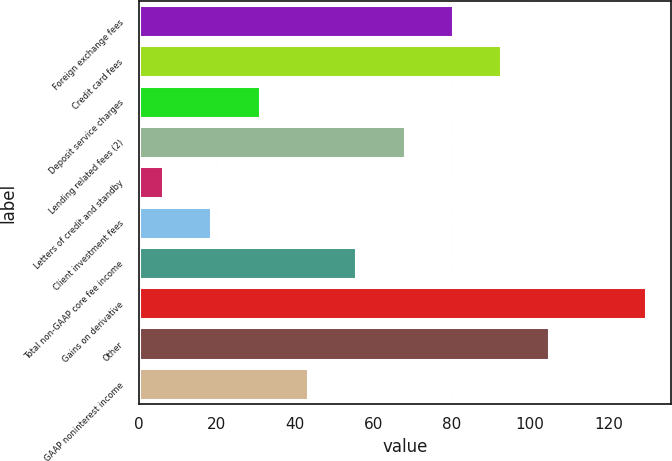<chart> <loc_0><loc_0><loc_500><loc_500><bar_chart><fcel>Foreign exchange fees<fcel>Credit card fees<fcel>Deposit service charges<fcel>Lending related fees (2)<fcel>Letters of credit and standby<fcel>Client investment fees<fcel>Total non-GAAP core fee income<fcel>Gains on derivative<fcel>Other<fcel>GAAP noninterest income<nl><fcel>80.28<fcel>92.61<fcel>30.96<fcel>67.95<fcel>6.3<fcel>18.63<fcel>55.62<fcel>129.6<fcel>104.94<fcel>43.29<nl></chart> 